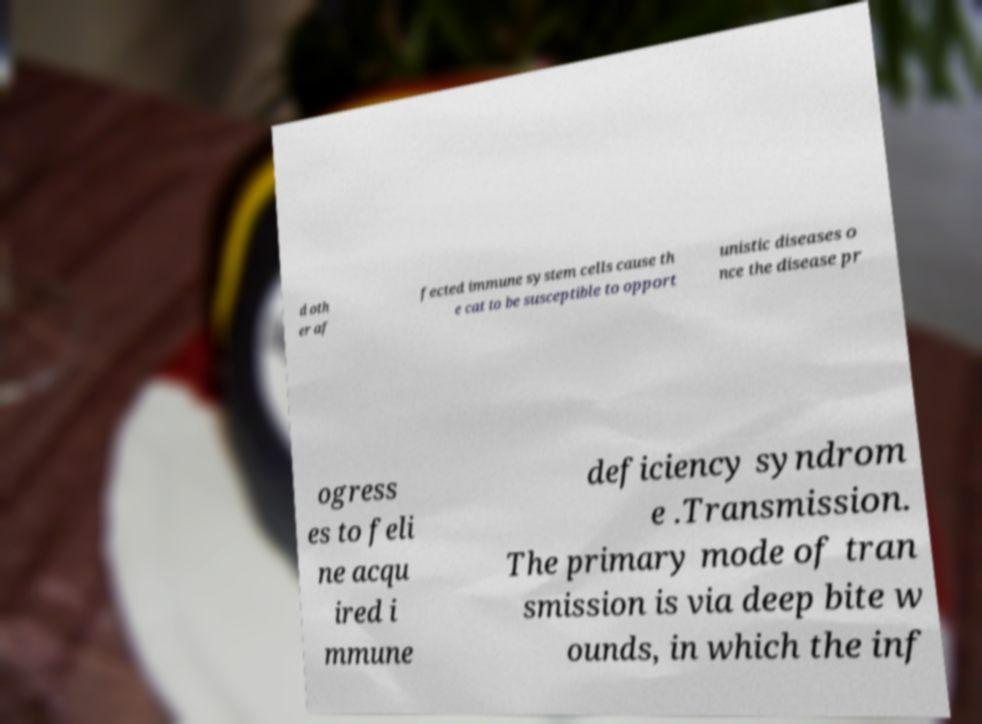Please read and relay the text visible in this image. What does it say? d oth er af fected immune system cells cause th e cat to be susceptible to opport unistic diseases o nce the disease pr ogress es to feli ne acqu ired i mmune deficiency syndrom e .Transmission. The primary mode of tran smission is via deep bite w ounds, in which the inf 